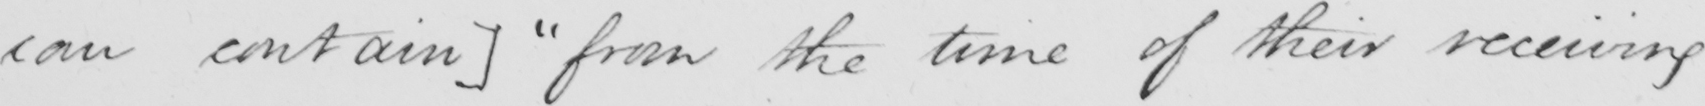Please provide the text content of this handwritten line. can contain ]   " from the time of their receiving 